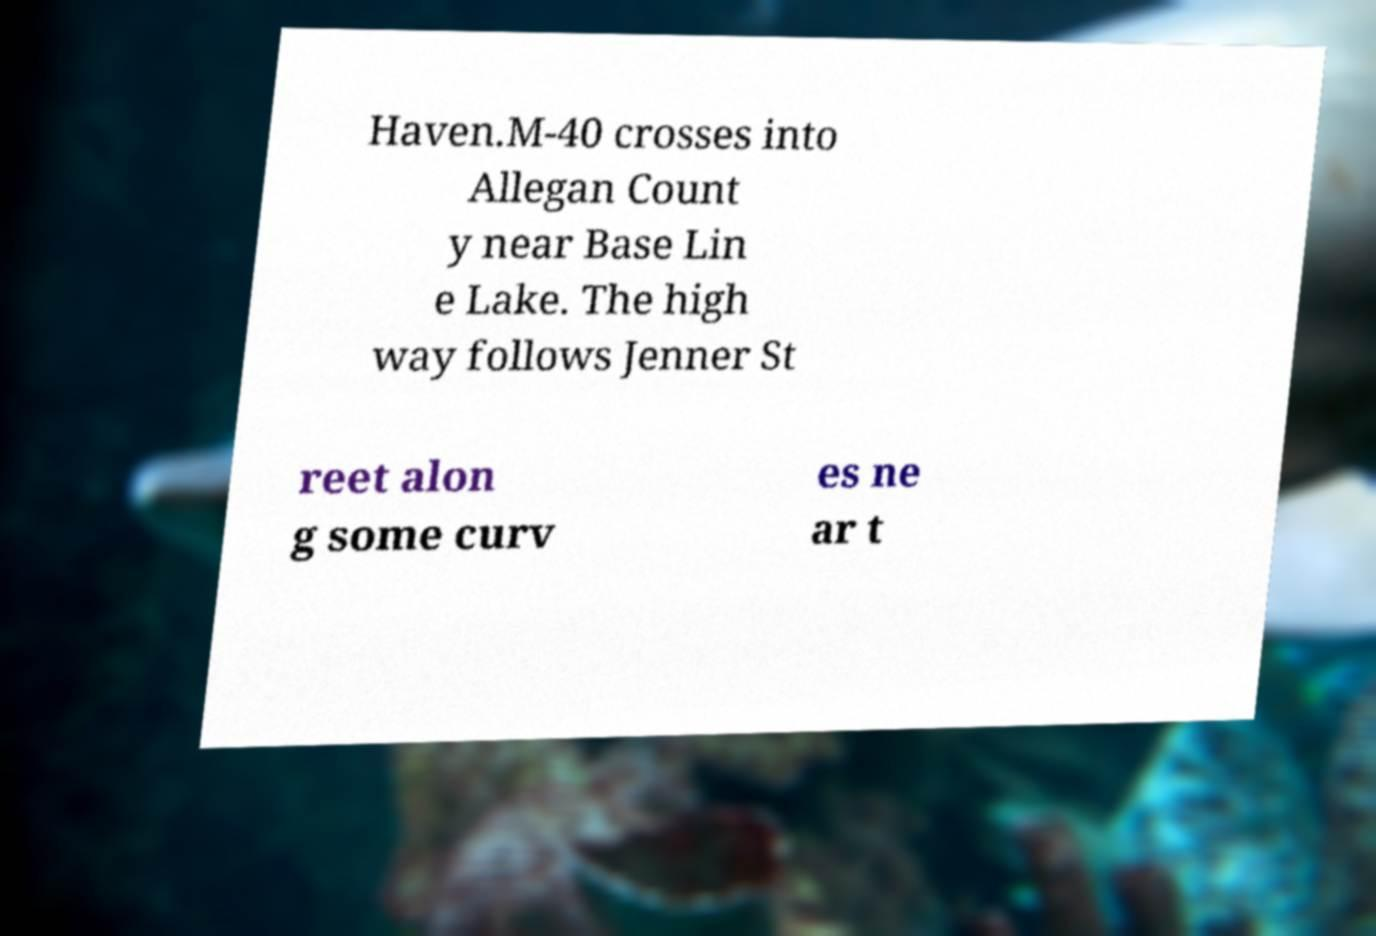Could you extract and type out the text from this image? Haven.M-40 crosses into Allegan Count y near Base Lin e Lake. The high way follows Jenner St reet alon g some curv es ne ar t 